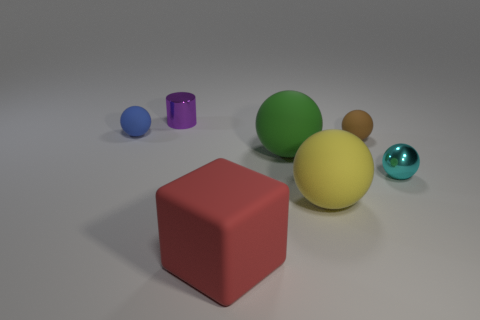How many red objects are either small cylinders or large blocks?
Offer a very short reply. 1. What is the size of the other object that is the same material as the purple thing?
Keep it short and to the point. Small. What number of cyan things are the same shape as the tiny purple shiny object?
Provide a short and direct response. 0. Is the number of big matte objects that are right of the green sphere greater than the number of big yellow rubber things on the right side of the brown rubber sphere?
Your response must be concise. Yes. What is the material of the yellow ball that is the same size as the red matte cube?
Keep it short and to the point. Rubber. How many things are tiny blue metallic balls or small balls that are in front of the big green matte ball?
Your answer should be compact. 1. There is a yellow rubber object; is it the same size as the brown matte thing that is behind the red object?
Make the answer very short. No. How many balls are either small cyan shiny things or red matte objects?
Give a very brief answer. 1. What number of small things are to the left of the tiny brown rubber thing and on the right side of the cylinder?
Make the answer very short. 0. How many other things are there of the same color as the cube?
Offer a terse response. 0. 